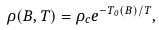Convert formula to latex. <formula><loc_0><loc_0><loc_500><loc_500>\rho ( B , T ) = \rho _ { c } e ^ { { - T _ { 0 } ( B ) } / { T } } ,</formula> 